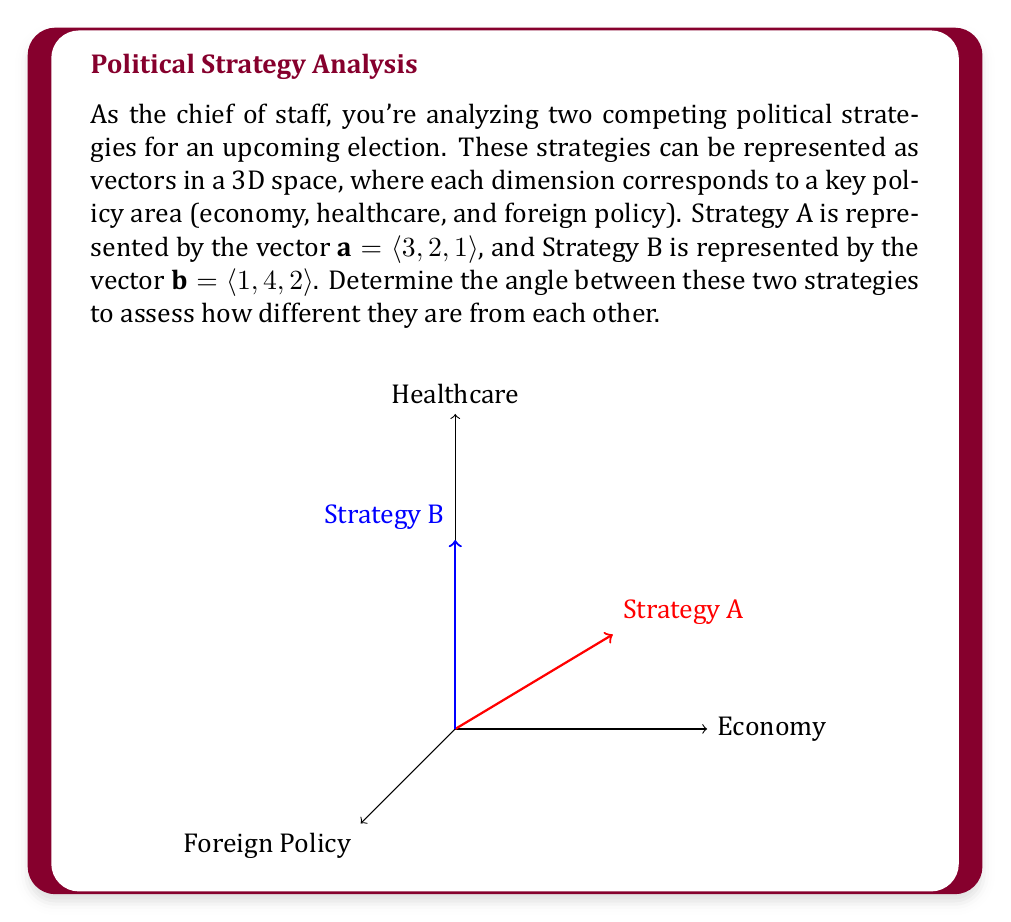What is the answer to this math problem? To find the angle between two vectors, we can use the dot product formula:

$$\cos \theta = \frac{\mathbf{a} \cdot \mathbf{b}}{|\mathbf{a}||\mathbf{b}|}$$

Where $\theta$ is the angle between the vectors, $\mathbf{a} \cdot \mathbf{b}$ is the dot product, and $|\mathbf{a}|$ and $|\mathbf{b}|$ are the magnitudes of the vectors.

Step 1: Calculate the dot product $\mathbf{a} \cdot \mathbf{b}$
$$\mathbf{a} \cdot \mathbf{b} = (3)(1) + (2)(4) + (1)(2) = 3 + 8 + 2 = 13$$

Step 2: Calculate the magnitudes of $\mathbf{a}$ and $\mathbf{b}$
$$|\mathbf{a}| = \sqrt{3^2 + 2^2 + 1^2} = \sqrt{14}$$
$$|\mathbf{b}| = \sqrt{1^2 + 4^2 + 2^2} = \sqrt{21}$$

Step 3: Apply the dot product formula
$$\cos \theta = \frac{13}{\sqrt{14}\sqrt{21}}$$

Step 4: Take the inverse cosine (arccos) of both sides
$$\theta = \arccos\left(\frac{13}{\sqrt{14}\sqrt{21}}\right)$$

Step 5: Calculate the result
$$\theta \approx 0.5738 \text{ radians}$$

Step 6: Convert to degrees
$$\theta \approx 32.88°$$

This angle represents the difference between the two political strategies. A smaller angle would indicate more similar strategies, while a larger angle would suggest more divergent approaches.
Answer: $32.88°$ 